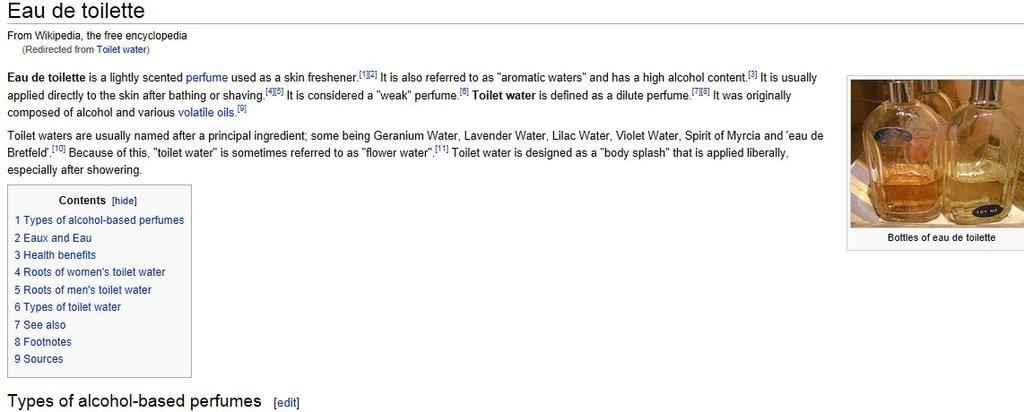Provide a one-sentence caption for the provided image. Wikipedia article for Eau de toilette showing a picture of two bottles. 